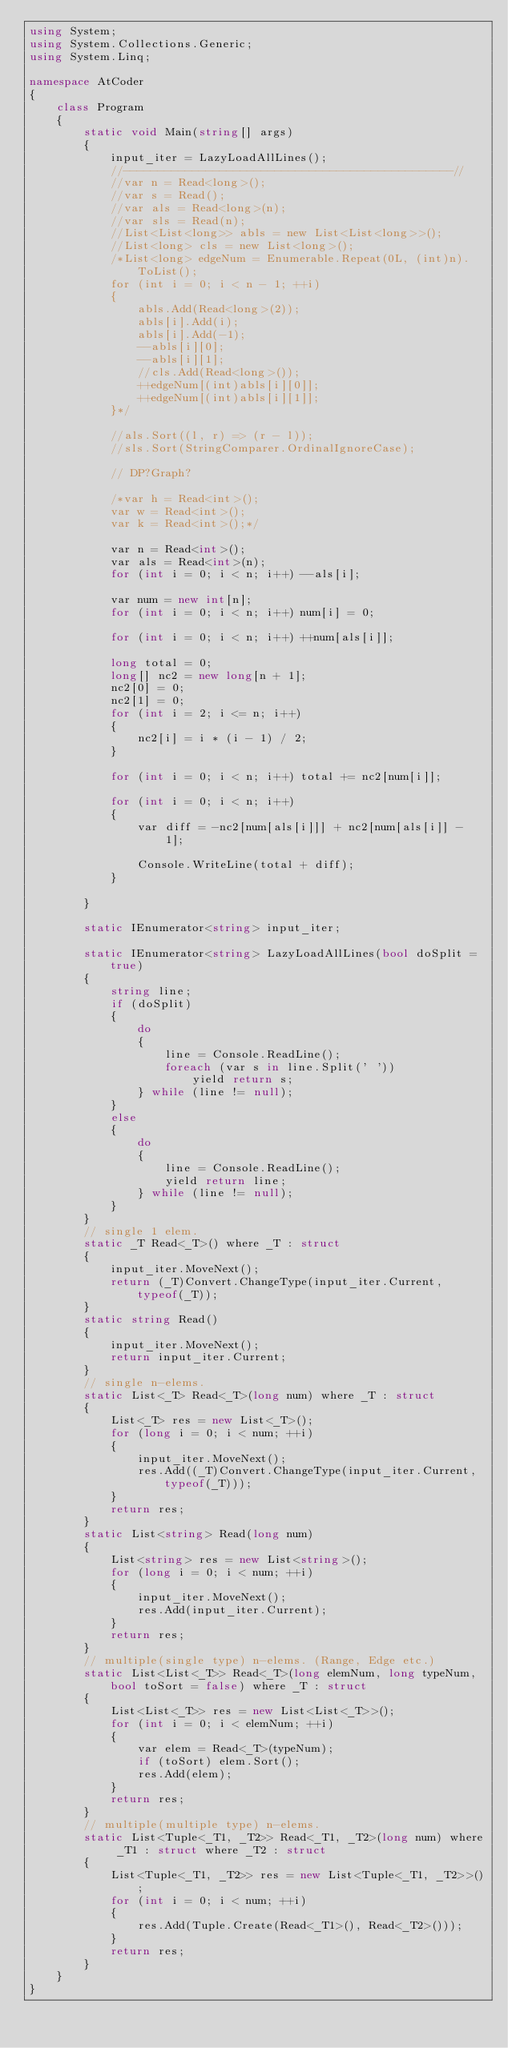<code> <loc_0><loc_0><loc_500><loc_500><_C#_>using System;
using System.Collections.Generic;
using System.Linq;

namespace AtCoder
{
    class Program
    {
        static void Main(string[] args)
        {
            input_iter = LazyLoadAllLines();
            //------------------------------------------------//
            //var n = Read<long>();
            //var s = Read();
            //var als = Read<long>(n);
            //var sls = Read(n);
            //List<List<long>> abls = new List<List<long>>();
            //List<long> cls = new List<long>();
            /*List<long> edgeNum = Enumerable.Repeat(0L, (int)n).ToList();
            for (int i = 0; i < n - 1; ++i)
            {
                abls.Add(Read<long>(2));
                abls[i].Add(i);
                abls[i].Add(-1);
                --abls[i][0];
                --abls[i][1];
                //cls.Add(Read<long>());
                ++edgeNum[(int)abls[i][0]];
                ++edgeNum[(int)abls[i][1]];
            }*/

            //als.Sort((l, r) => (r - l));
            //sls.Sort(StringComparer.OrdinalIgnoreCase);

            // DP?Graph?

            /*var h = Read<int>();
            var w = Read<int>();
            var k = Read<int>();*/

            var n = Read<int>();
            var als = Read<int>(n);
            for (int i = 0; i < n; i++) --als[i];

            var num = new int[n];
            for (int i = 0; i < n; i++) num[i] = 0;

            for (int i = 0; i < n; i++) ++num[als[i]];

            long total = 0;
            long[] nc2 = new long[n + 1];
            nc2[0] = 0;
            nc2[1] = 0;
            for (int i = 2; i <= n; i++)
            {
                nc2[i] = i * (i - 1) / 2;
            }

            for (int i = 0; i < n; i++) total += nc2[num[i]];

            for (int i = 0; i < n; i++)
            {
                var diff = -nc2[num[als[i]]] + nc2[num[als[i]] - 1];

                Console.WriteLine(total + diff);
            }

        }

        static IEnumerator<string> input_iter;

        static IEnumerator<string> LazyLoadAllLines(bool doSplit = true)
        {
            string line;
            if (doSplit)
            {
                do
                {
                    line = Console.ReadLine();
                    foreach (var s in line.Split(' '))
                        yield return s;
                } while (line != null);
            }
            else
            {
                do
                {
                    line = Console.ReadLine();
                    yield return line;
                } while (line != null);
            }
        }
        // single 1 elem.
        static _T Read<_T>() where _T : struct
        {
            input_iter.MoveNext();
            return (_T)Convert.ChangeType(input_iter.Current, typeof(_T));
        }
        static string Read()
        {
            input_iter.MoveNext();
            return input_iter.Current;
        }
        // single n-elems.
        static List<_T> Read<_T>(long num) where _T : struct
        {
            List<_T> res = new List<_T>();
            for (long i = 0; i < num; ++i)
            {
                input_iter.MoveNext();
                res.Add((_T)Convert.ChangeType(input_iter.Current, typeof(_T)));
            }
            return res;
        }
        static List<string> Read(long num)
        {
            List<string> res = new List<string>();
            for (long i = 0; i < num; ++i)
            {
                input_iter.MoveNext();
                res.Add(input_iter.Current);
            }
            return res;
        }
        // multiple(single type) n-elems. (Range, Edge etc.)
        static List<List<_T>> Read<_T>(long elemNum, long typeNum, bool toSort = false) where _T : struct
        {
            List<List<_T>> res = new List<List<_T>>();
            for (int i = 0; i < elemNum; ++i)
            {
                var elem = Read<_T>(typeNum);
                if (toSort) elem.Sort();
                res.Add(elem);
            }
            return res;
        }
        // multiple(multiple type) n-elems.
        static List<Tuple<_T1, _T2>> Read<_T1, _T2>(long num) where _T1 : struct where _T2 : struct
        {
            List<Tuple<_T1, _T2>> res = new List<Tuple<_T1, _T2>>();
            for (int i = 0; i < num; ++i)
            {
                res.Add(Tuple.Create(Read<_T1>(), Read<_T2>()));
            }
            return res;
        }
    }
}
</code> 